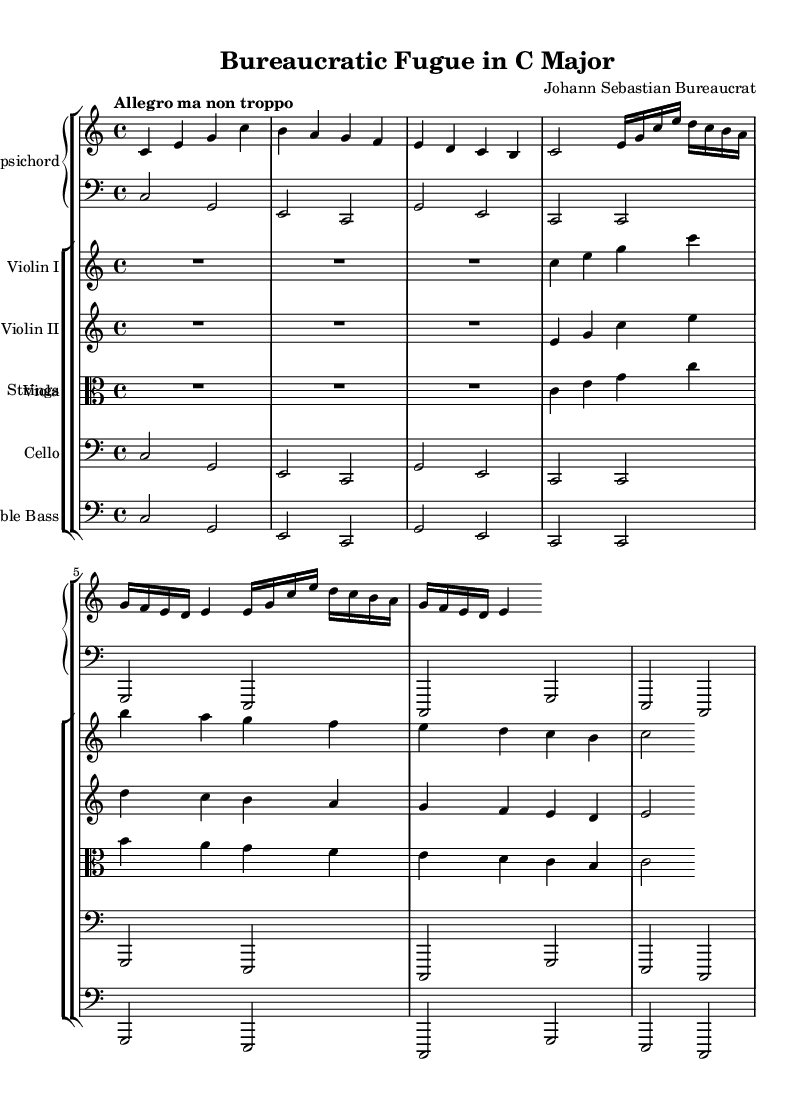What is the key signature of this music? The key signature is C major, which has no sharps or flats.
Answer: C major What is the time signature of the piece? The time signature shown at the beginning of the score is 4/4, indicating four beats in a measure.
Answer: 4/4 What is the tempo marking for this concerto? The tempo marking states "Allegro ma non troppo," suggesting a lively tempo, but not too fast.
Answer: Allegro ma non troppo How many measures are in the Harpsichord part? By counting the measures indicated in the Harpsichord section, there are a total of 6 measures presented.
Answer: 6 What is the instrumentation used in this piece? The instrumentation includes Harpsichord, Violin I, Violin II, Viola, Cello, and Double Bass as specified in the score layout.
Answer: Harpsichord, Violin I, Violin II, Viola, Cello, Double Bass How many times is the "e" note repeated in the Harpsichord part? The note "e" appears multiple times; upon careful examination, it is repeated a total of 6 times in the specified section.
Answer: 6 